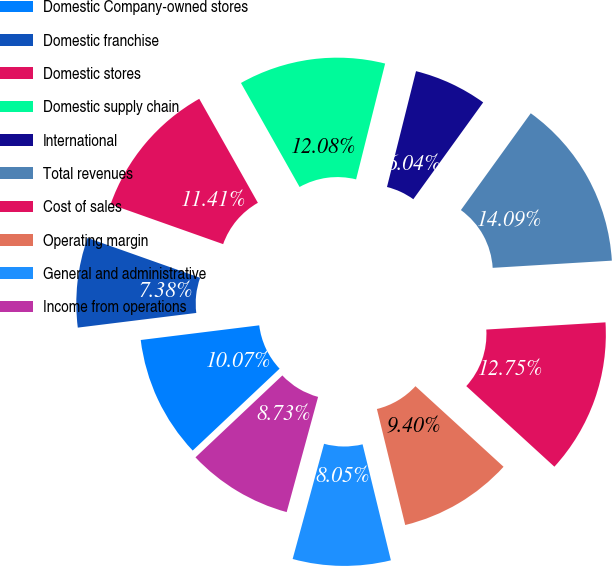Convert chart. <chart><loc_0><loc_0><loc_500><loc_500><pie_chart><fcel>Domestic Company-owned stores<fcel>Domestic franchise<fcel>Domestic stores<fcel>Domestic supply chain<fcel>International<fcel>Total revenues<fcel>Cost of sales<fcel>Operating margin<fcel>General and administrative<fcel>Income from operations<nl><fcel>10.07%<fcel>7.38%<fcel>11.41%<fcel>12.08%<fcel>6.04%<fcel>14.09%<fcel>12.75%<fcel>9.4%<fcel>8.05%<fcel>8.73%<nl></chart> 